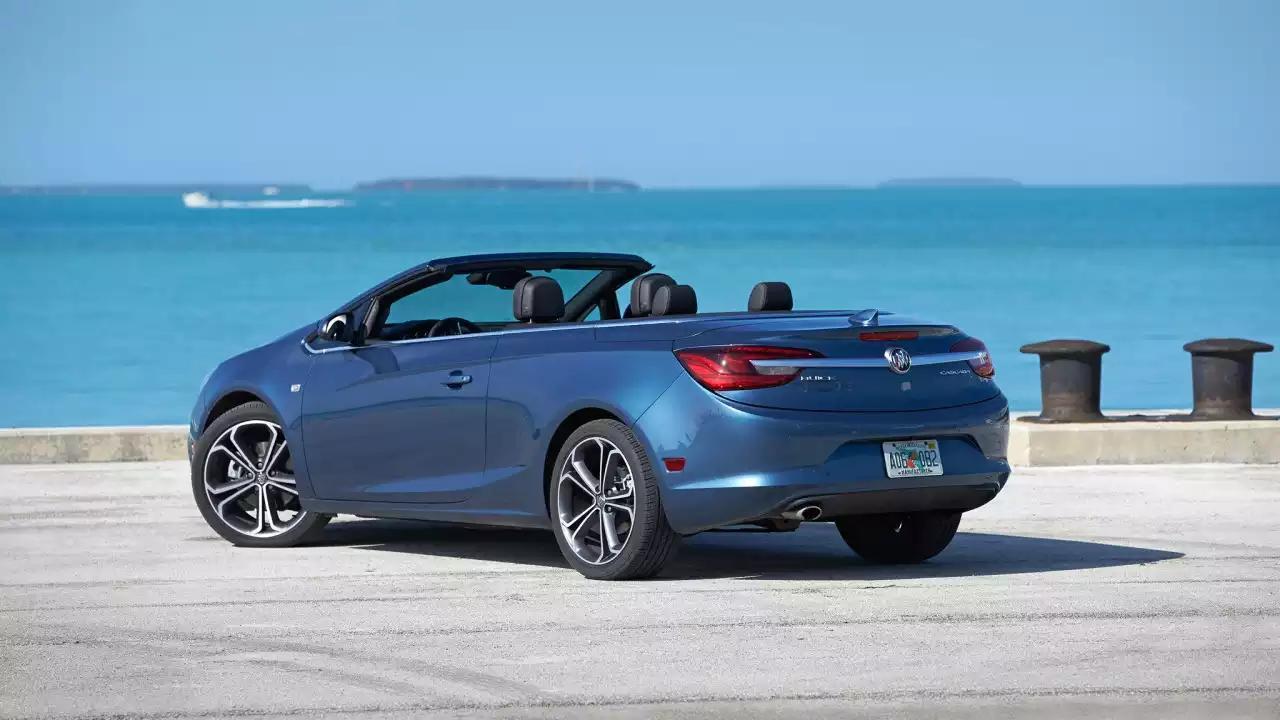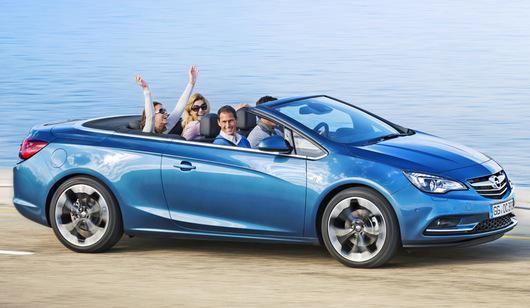The first image is the image on the left, the second image is the image on the right. For the images displayed, is the sentence "There is more than one person in the car in the image on the right." factually correct? Answer yes or no. Yes. The first image is the image on the left, the second image is the image on the right. Evaluate the accuracy of this statement regarding the images: "Each image contains a single blue convertible with its top down, and at least one has a driver.". Is it true? Answer yes or no. Yes. 